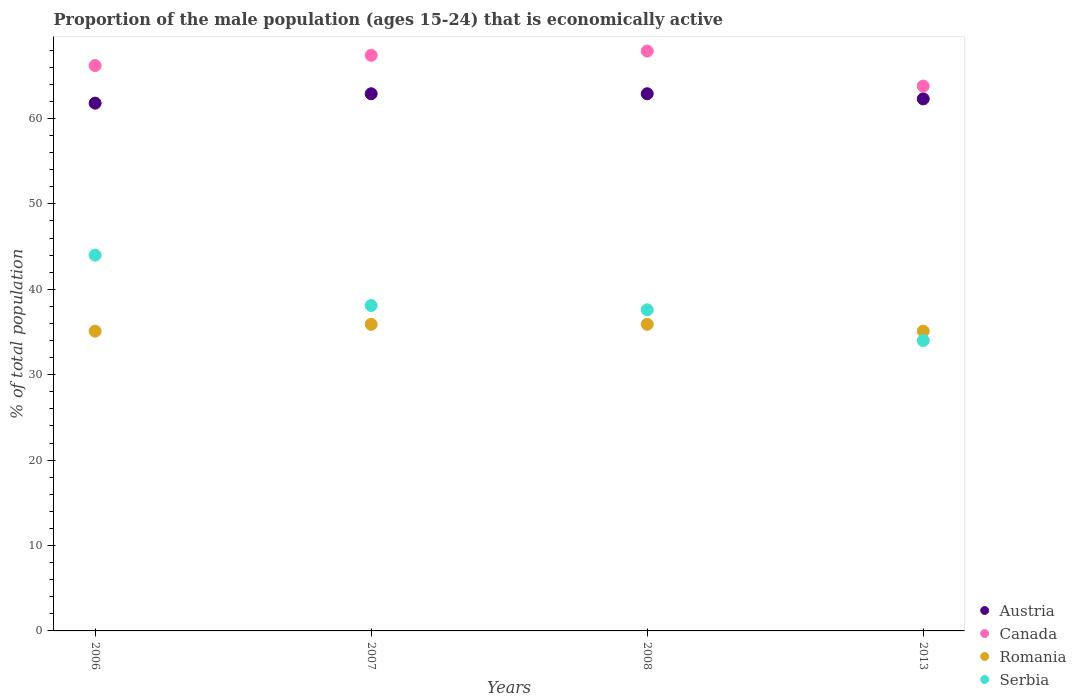How many different coloured dotlines are there?
Give a very brief answer. 4. What is the proportion of the male population that is economically active in Austria in 2007?
Keep it short and to the point. 62.9. Across all years, what is the minimum proportion of the male population that is economically active in Austria?
Provide a succinct answer. 61.8. In which year was the proportion of the male population that is economically active in Canada minimum?
Provide a succinct answer. 2013. What is the total proportion of the male population that is economically active in Austria in the graph?
Provide a short and direct response. 249.9. What is the difference between the proportion of the male population that is economically active in Serbia in 2008 and that in 2013?
Your answer should be compact. 3.6. What is the difference between the proportion of the male population that is economically active in Canada in 2013 and the proportion of the male population that is economically active in Serbia in 2007?
Your response must be concise. 25.7. What is the average proportion of the male population that is economically active in Serbia per year?
Your answer should be very brief. 38.42. In the year 2008, what is the difference between the proportion of the male population that is economically active in Austria and proportion of the male population that is economically active in Serbia?
Ensure brevity in your answer.  25.3. What is the ratio of the proportion of the male population that is economically active in Canada in 2006 to that in 2007?
Provide a succinct answer. 0.98. Is the difference between the proportion of the male population that is economically active in Austria in 2006 and 2007 greater than the difference between the proportion of the male population that is economically active in Serbia in 2006 and 2007?
Offer a very short reply. No. What is the difference between the highest and the second highest proportion of the male population that is economically active in Canada?
Give a very brief answer. 0.5. What is the difference between the highest and the lowest proportion of the male population that is economically active in Serbia?
Offer a terse response. 10. Is the sum of the proportion of the male population that is economically active in Austria in 2007 and 2008 greater than the maximum proportion of the male population that is economically active in Canada across all years?
Your answer should be compact. Yes. Is it the case that in every year, the sum of the proportion of the male population that is economically active in Romania and proportion of the male population that is economically active in Serbia  is greater than the sum of proportion of the male population that is economically active in Canada and proportion of the male population that is economically active in Austria?
Ensure brevity in your answer.  No. Does the proportion of the male population that is economically active in Austria monotonically increase over the years?
Keep it short and to the point. No. Is the proportion of the male population that is economically active in Romania strictly less than the proportion of the male population that is economically active in Canada over the years?
Your answer should be very brief. Yes. How many years are there in the graph?
Provide a succinct answer. 4. What is the difference between two consecutive major ticks on the Y-axis?
Keep it short and to the point. 10. Are the values on the major ticks of Y-axis written in scientific E-notation?
Keep it short and to the point. No. Where does the legend appear in the graph?
Provide a short and direct response. Bottom right. What is the title of the graph?
Your answer should be compact. Proportion of the male population (ages 15-24) that is economically active. Does "Canada" appear as one of the legend labels in the graph?
Your response must be concise. Yes. What is the label or title of the Y-axis?
Give a very brief answer. % of total population. What is the % of total population of Austria in 2006?
Ensure brevity in your answer.  61.8. What is the % of total population in Canada in 2006?
Provide a short and direct response. 66.2. What is the % of total population of Romania in 2006?
Offer a very short reply. 35.1. What is the % of total population of Austria in 2007?
Your answer should be compact. 62.9. What is the % of total population of Canada in 2007?
Give a very brief answer. 67.4. What is the % of total population in Romania in 2007?
Provide a succinct answer. 35.9. What is the % of total population of Serbia in 2007?
Your answer should be compact. 38.1. What is the % of total population in Austria in 2008?
Provide a short and direct response. 62.9. What is the % of total population of Canada in 2008?
Give a very brief answer. 67.9. What is the % of total population of Romania in 2008?
Provide a succinct answer. 35.9. What is the % of total population in Serbia in 2008?
Offer a very short reply. 37.6. What is the % of total population in Austria in 2013?
Your answer should be very brief. 62.3. What is the % of total population in Canada in 2013?
Your response must be concise. 63.8. What is the % of total population of Romania in 2013?
Give a very brief answer. 35.1. What is the % of total population in Serbia in 2013?
Provide a succinct answer. 34. Across all years, what is the maximum % of total population in Austria?
Give a very brief answer. 62.9. Across all years, what is the maximum % of total population in Canada?
Provide a succinct answer. 67.9. Across all years, what is the maximum % of total population of Romania?
Give a very brief answer. 35.9. Across all years, what is the maximum % of total population of Serbia?
Provide a succinct answer. 44. Across all years, what is the minimum % of total population of Austria?
Make the answer very short. 61.8. Across all years, what is the minimum % of total population of Canada?
Offer a very short reply. 63.8. Across all years, what is the minimum % of total population of Romania?
Offer a terse response. 35.1. What is the total % of total population in Austria in the graph?
Offer a terse response. 249.9. What is the total % of total population of Canada in the graph?
Your response must be concise. 265.3. What is the total % of total population in Romania in the graph?
Make the answer very short. 142. What is the total % of total population of Serbia in the graph?
Provide a succinct answer. 153.7. What is the difference between the % of total population of Austria in 2006 and that in 2007?
Keep it short and to the point. -1.1. What is the difference between the % of total population of Canada in 2006 and that in 2007?
Give a very brief answer. -1.2. What is the difference between the % of total population of Serbia in 2006 and that in 2007?
Provide a short and direct response. 5.9. What is the difference between the % of total population of Canada in 2006 and that in 2008?
Give a very brief answer. -1.7. What is the difference between the % of total population in Serbia in 2006 and that in 2008?
Provide a succinct answer. 6.4. What is the difference between the % of total population of Austria in 2006 and that in 2013?
Provide a short and direct response. -0.5. What is the difference between the % of total population in Canada in 2006 and that in 2013?
Your response must be concise. 2.4. What is the difference between the % of total population of Serbia in 2006 and that in 2013?
Make the answer very short. 10. What is the difference between the % of total population in Canada in 2007 and that in 2008?
Your response must be concise. -0.5. What is the difference between the % of total population in Romania in 2007 and that in 2008?
Offer a terse response. 0. What is the difference between the % of total population in Serbia in 2007 and that in 2008?
Offer a terse response. 0.5. What is the difference between the % of total population in Austria in 2008 and that in 2013?
Keep it short and to the point. 0.6. What is the difference between the % of total population in Romania in 2008 and that in 2013?
Give a very brief answer. 0.8. What is the difference between the % of total population of Austria in 2006 and the % of total population of Romania in 2007?
Your response must be concise. 25.9. What is the difference between the % of total population of Austria in 2006 and the % of total population of Serbia in 2007?
Keep it short and to the point. 23.7. What is the difference between the % of total population of Canada in 2006 and the % of total population of Romania in 2007?
Provide a succinct answer. 30.3. What is the difference between the % of total population in Canada in 2006 and the % of total population in Serbia in 2007?
Offer a terse response. 28.1. What is the difference between the % of total population of Austria in 2006 and the % of total population of Romania in 2008?
Give a very brief answer. 25.9. What is the difference between the % of total population in Austria in 2006 and the % of total population in Serbia in 2008?
Make the answer very short. 24.2. What is the difference between the % of total population in Canada in 2006 and the % of total population in Romania in 2008?
Provide a succinct answer. 30.3. What is the difference between the % of total population of Canada in 2006 and the % of total population of Serbia in 2008?
Make the answer very short. 28.6. What is the difference between the % of total population of Romania in 2006 and the % of total population of Serbia in 2008?
Offer a terse response. -2.5. What is the difference between the % of total population of Austria in 2006 and the % of total population of Romania in 2013?
Offer a terse response. 26.7. What is the difference between the % of total population in Austria in 2006 and the % of total population in Serbia in 2013?
Your response must be concise. 27.8. What is the difference between the % of total population of Canada in 2006 and the % of total population of Romania in 2013?
Your answer should be very brief. 31.1. What is the difference between the % of total population in Canada in 2006 and the % of total population in Serbia in 2013?
Provide a short and direct response. 32.2. What is the difference between the % of total population of Austria in 2007 and the % of total population of Canada in 2008?
Make the answer very short. -5. What is the difference between the % of total population of Austria in 2007 and the % of total population of Serbia in 2008?
Give a very brief answer. 25.3. What is the difference between the % of total population of Canada in 2007 and the % of total population of Romania in 2008?
Your answer should be very brief. 31.5. What is the difference between the % of total population in Canada in 2007 and the % of total population in Serbia in 2008?
Provide a succinct answer. 29.8. What is the difference between the % of total population of Austria in 2007 and the % of total population of Canada in 2013?
Provide a short and direct response. -0.9. What is the difference between the % of total population in Austria in 2007 and the % of total population in Romania in 2013?
Provide a succinct answer. 27.8. What is the difference between the % of total population of Austria in 2007 and the % of total population of Serbia in 2013?
Offer a very short reply. 28.9. What is the difference between the % of total population of Canada in 2007 and the % of total population of Romania in 2013?
Offer a very short reply. 32.3. What is the difference between the % of total population in Canada in 2007 and the % of total population in Serbia in 2013?
Keep it short and to the point. 33.4. What is the difference between the % of total population of Austria in 2008 and the % of total population of Romania in 2013?
Provide a succinct answer. 27.8. What is the difference between the % of total population in Austria in 2008 and the % of total population in Serbia in 2013?
Ensure brevity in your answer.  28.9. What is the difference between the % of total population of Canada in 2008 and the % of total population of Romania in 2013?
Offer a terse response. 32.8. What is the difference between the % of total population of Canada in 2008 and the % of total population of Serbia in 2013?
Provide a succinct answer. 33.9. What is the average % of total population of Austria per year?
Keep it short and to the point. 62.48. What is the average % of total population of Canada per year?
Ensure brevity in your answer.  66.33. What is the average % of total population of Romania per year?
Make the answer very short. 35.5. What is the average % of total population of Serbia per year?
Ensure brevity in your answer.  38.42. In the year 2006, what is the difference between the % of total population in Austria and % of total population in Romania?
Offer a very short reply. 26.7. In the year 2006, what is the difference between the % of total population of Austria and % of total population of Serbia?
Your response must be concise. 17.8. In the year 2006, what is the difference between the % of total population of Canada and % of total population of Romania?
Ensure brevity in your answer.  31.1. In the year 2006, what is the difference between the % of total population of Canada and % of total population of Serbia?
Make the answer very short. 22.2. In the year 2007, what is the difference between the % of total population in Austria and % of total population in Romania?
Keep it short and to the point. 27. In the year 2007, what is the difference between the % of total population of Austria and % of total population of Serbia?
Your answer should be compact. 24.8. In the year 2007, what is the difference between the % of total population in Canada and % of total population in Romania?
Your response must be concise. 31.5. In the year 2007, what is the difference between the % of total population in Canada and % of total population in Serbia?
Offer a very short reply. 29.3. In the year 2007, what is the difference between the % of total population of Romania and % of total population of Serbia?
Provide a succinct answer. -2.2. In the year 2008, what is the difference between the % of total population of Austria and % of total population of Canada?
Your response must be concise. -5. In the year 2008, what is the difference between the % of total population of Austria and % of total population of Serbia?
Offer a very short reply. 25.3. In the year 2008, what is the difference between the % of total population in Canada and % of total population in Serbia?
Provide a short and direct response. 30.3. In the year 2013, what is the difference between the % of total population of Austria and % of total population of Canada?
Make the answer very short. -1.5. In the year 2013, what is the difference between the % of total population of Austria and % of total population of Romania?
Your response must be concise. 27.2. In the year 2013, what is the difference between the % of total population of Austria and % of total population of Serbia?
Your answer should be compact. 28.3. In the year 2013, what is the difference between the % of total population in Canada and % of total population in Romania?
Offer a terse response. 28.7. In the year 2013, what is the difference between the % of total population in Canada and % of total population in Serbia?
Provide a succinct answer. 29.8. What is the ratio of the % of total population in Austria in 2006 to that in 2007?
Give a very brief answer. 0.98. What is the ratio of the % of total population of Canada in 2006 to that in 2007?
Your answer should be compact. 0.98. What is the ratio of the % of total population of Romania in 2006 to that in 2007?
Make the answer very short. 0.98. What is the ratio of the % of total population in Serbia in 2006 to that in 2007?
Make the answer very short. 1.15. What is the ratio of the % of total population in Austria in 2006 to that in 2008?
Provide a succinct answer. 0.98. What is the ratio of the % of total population of Canada in 2006 to that in 2008?
Provide a short and direct response. 0.97. What is the ratio of the % of total population in Romania in 2006 to that in 2008?
Offer a very short reply. 0.98. What is the ratio of the % of total population of Serbia in 2006 to that in 2008?
Make the answer very short. 1.17. What is the ratio of the % of total population of Canada in 2006 to that in 2013?
Provide a succinct answer. 1.04. What is the ratio of the % of total population of Serbia in 2006 to that in 2013?
Offer a terse response. 1.29. What is the ratio of the % of total population in Austria in 2007 to that in 2008?
Offer a terse response. 1. What is the ratio of the % of total population of Romania in 2007 to that in 2008?
Keep it short and to the point. 1. What is the ratio of the % of total population in Serbia in 2007 to that in 2008?
Give a very brief answer. 1.01. What is the ratio of the % of total population of Austria in 2007 to that in 2013?
Provide a short and direct response. 1.01. What is the ratio of the % of total population of Canada in 2007 to that in 2013?
Provide a short and direct response. 1.06. What is the ratio of the % of total population in Romania in 2007 to that in 2013?
Provide a short and direct response. 1.02. What is the ratio of the % of total population in Serbia in 2007 to that in 2013?
Make the answer very short. 1.12. What is the ratio of the % of total population in Austria in 2008 to that in 2013?
Provide a short and direct response. 1.01. What is the ratio of the % of total population in Canada in 2008 to that in 2013?
Offer a very short reply. 1.06. What is the ratio of the % of total population of Romania in 2008 to that in 2013?
Your response must be concise. 1.02. What is the ratio of the % of total population of Serbia in 2008 to that in 2013?
Keep it short and to the point. 1.11. What is the difference between the highest and the second highest % of total population in Austria?
Make the answer very short. 0. What is the difference between the highest and the second highest % of total population of Canada?
Your answer should be compact. 0.5. What is the difference between the highest and the lowest % of total population in Austria?
Provide a succinct answer. 1.1. What is the difference between the highest and the lowest % of total population of Canada?
Make the answer very short. 4.1. What is the difference between the highest and the lowest % of total population in Romania?
Your answer should be compact. 0.8. What is the difference between the highest and the lowest % of total population in Serbia?
Keep it short and to the point. 10. 